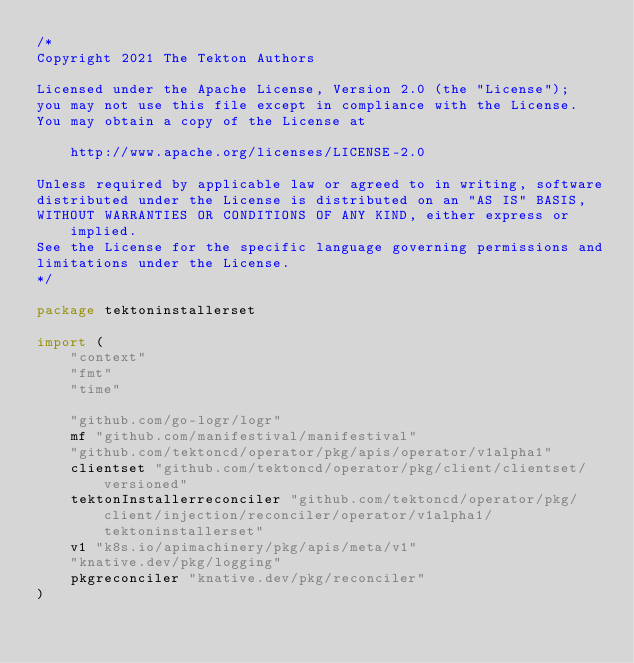Convert code to text. <code><loc_0><loc_0><loc_500><loc_500><_Go_>/*
Copyright 2021 The Tekton Authors

Licensed under the Apache License, Version 2.0 (the "License");
you may not use this file except in compliance with the License.
You may obtain a copy of the License at

    http://www.apache.org/licenses/LICENSE-2.0

Unless required by applicable law or agreed to in writing, software
distributed under the License is distributed on an "AS IS" BASIS,
WITHOUT WARRANTIES OR CONDITIONS OF ANY KIND, either express or implied.
See the License for the specific language governing permissions and
limitations under the License.
*/

package tektoninstallerset

import (
	"context"
	"fmt"
	"time"

	"github.com/go-logr/logr"
	mf "github.com/manifestival/manifestival"
	"github.com/tektoncd/operator/pkg/apis/operator/v1alpha1"
	clientset "github.com/tektoncd/operator/pkg/client/clientset/versioned"
	tektonInstallerreconciler "github.com/tektoncd/operator/pkg/client/injection/reconciler/operator/v1alpha1/tektoninstallerset"
	v1 "k8s.io/apimachinery/pkg/apis/meta/v1"
	"knative.dev/pkg/logging"
	pkgreconciler "knative.dev/pkg/reconciler"
)
</code> 